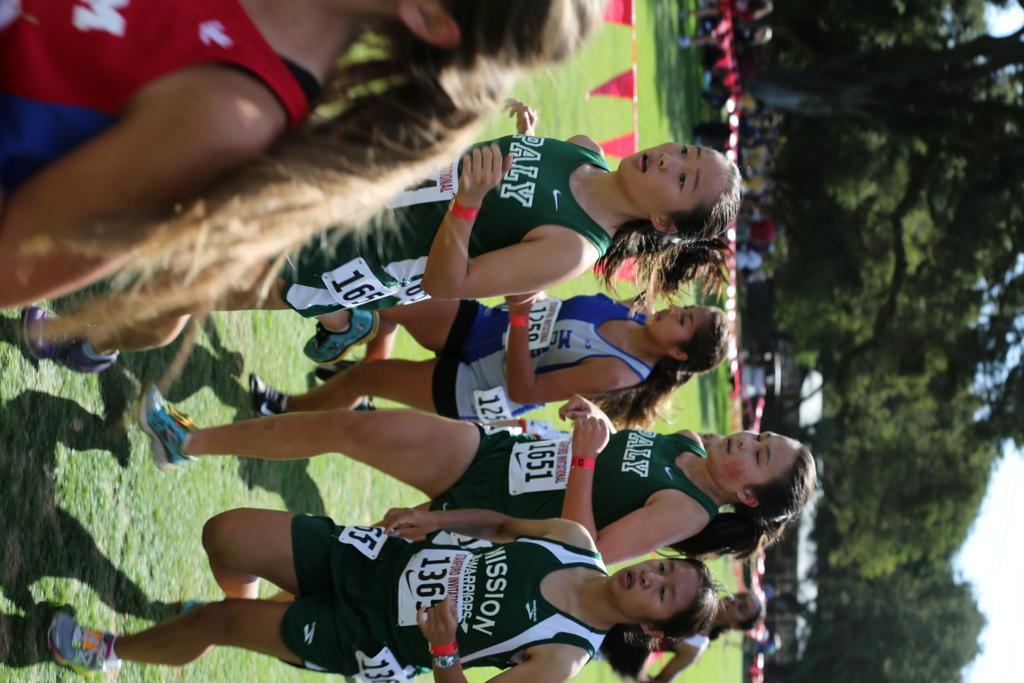Describe this image in one or two sentences. In the middle of the image few people are running. On the right side of the image we can see some trees and house and few people are standing and watching and there are some vehicles. In the bottom right corner of the image there is sky. 